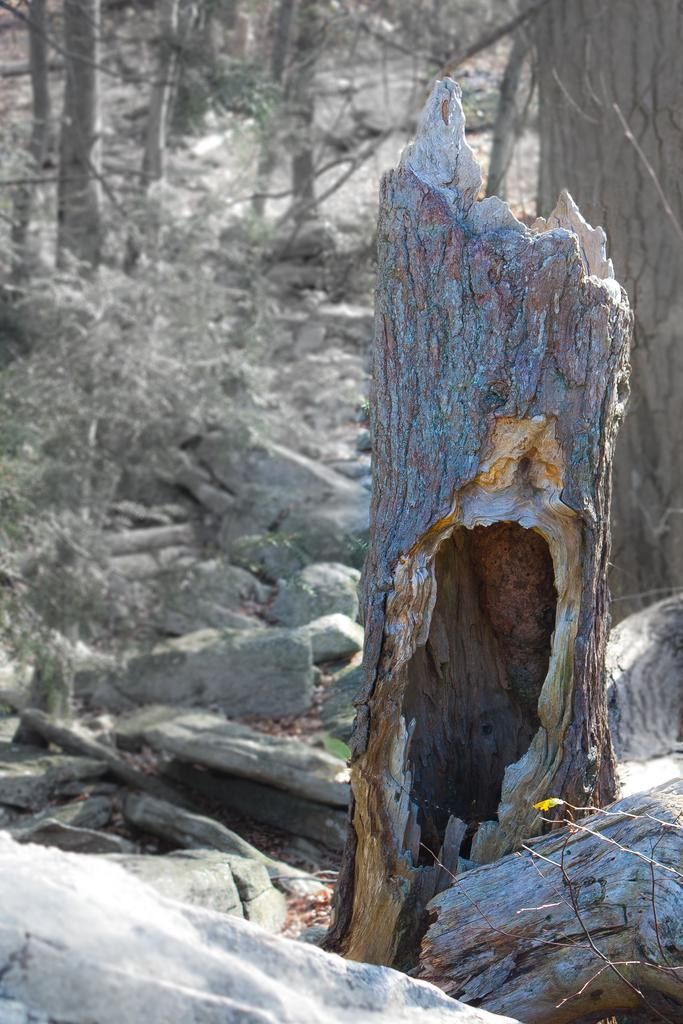What is the setting of the image? The image has an outside view. What can be seen in the middle of the image? There is a log in the middle of the image. What type of natural environment is visible in the background? There are trees in the background of the image. Where are the cherries placed on the log in the image? There are no cherries present in the image. What type of crown can be seen on the log in the image? There is no crown present on the log or in the image. 